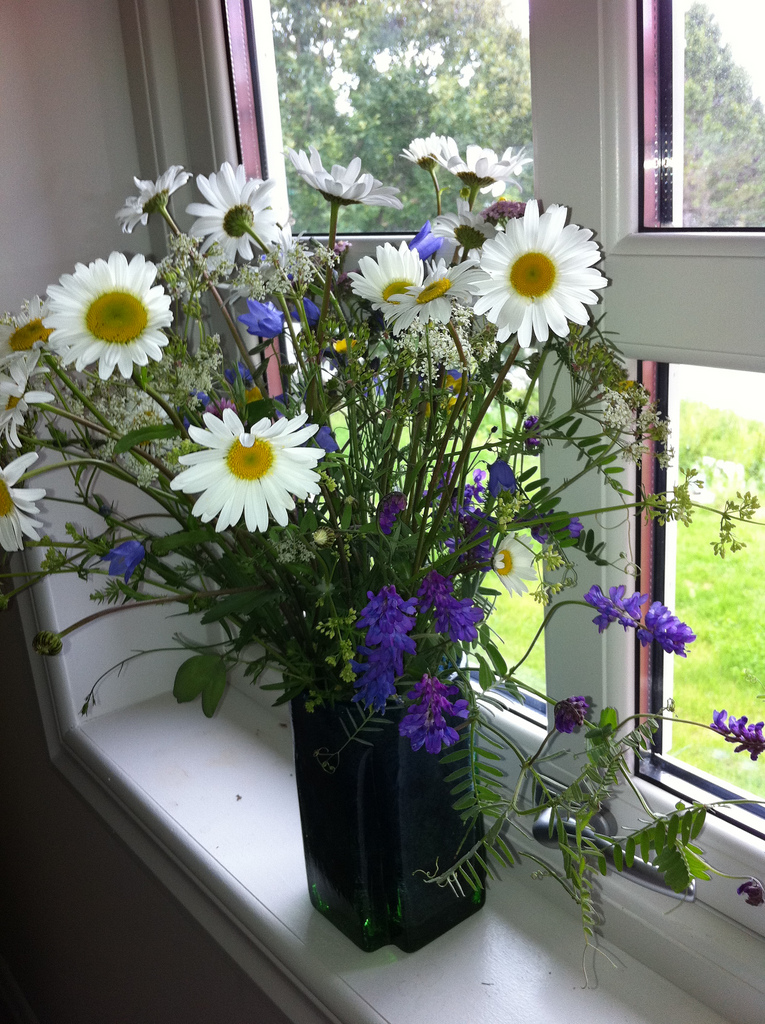Are there any trays or folding chairs in the scene? No, there are no trays or folding chairs visible in the scene. 